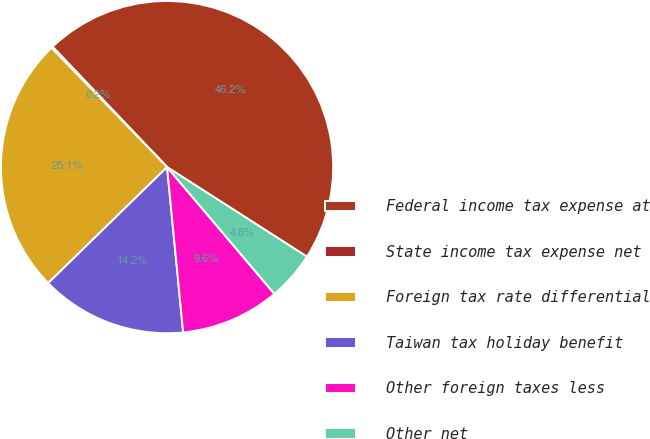<chart> <loc_0><loc_0><loc_500><loc_500><pie_chart><fcel>Federal income tax expense at<fcel>State income tax expense net<fcel>Foreign tax rate differential<fcel>Taiwan tax holiday benefit<fcel>Other foreign taxes less<fcel>Other net<nl><fcel>46.17%<fcel>0.15%<fcel>25.05%<fcel>14.24%<fcel>9.64%<fcel>4.75%<nl></chart> 